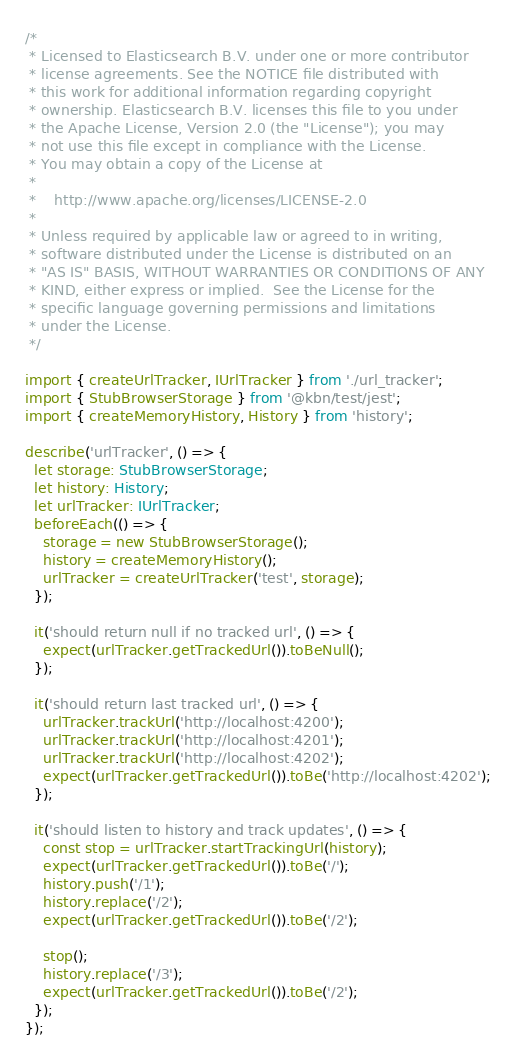<code> <loc_0><loc_0><loc_500><loc_500><_TypeScript_>/*
 * Licensed to Elasticsearch B.V. under one or more contributor
 * license agreements. See the NOTICE file distributed with
 * this work for additional information regarding copyright
 * ownership. Elasticsearch B.V. licenses this file to you under
 * the Apache License, Version 2.0 (the "License"); you may
 * not use this file except in compliance with the License.
 * You may obtain a copy of the License at
 *
 *    http://www.apache.org/licenses/LICENSE-2.0
 *
 * Unless required by applicable law or agreed to in writing,
 * software distributed under the License is distributed on an
 * "AS IS" BASIS, WITHOUT WARRANTIES OR CONDITIONS OF ANY
 * KIND, either express or implied.  See the License for the
 * specific language governing permissions and limitations
 * under the License.
 */

import { createUrlTracker, IUrlTracker } from './url_tracker';
import { StubBrowserStorage } from '@kbn/test/jest';
import { createMemoryHistory, History } from 'history';

describe('urlTracker', () => {
  let storage: StubBrowserStorage;
  let history: History;
  let urlTracker: IUrlTracker;
  beforeEach(() => {
    storage = new StubBrowserStorage();
    history = createMemoryHistory();
    urlTracker = createUrlTracker('test', storage);
  });

  it('should return null if no tracked url', () => {
    expect(urlTracker.getTrackedUrl()).toBeNull();
  });

  it('should return last tracked url', () => {
    urlTracker.trackUrl('http://localhost:4200');
    urlTracker.trackUrl('http://localhost:4201');
    urlTracker.trackUrl('http://localhost:4202');
    expect(urlTracker.getTrackedUrl()).toBe('http://localhost:4202');
  });

  it('should listen to history and track updates', () => {
    const stop = urlTracker.startTrackingUrl(history);
    expect(urlTracker.getTrackedUrl()).toBe('/');
    history.push('/1');
    history.replace('/2');
    expect(urlTracker.getTrackedUrl()).toBe('/2');

    stop();
    history.replace('/3');
    expect(urlTracker.getTrackedUrl()).toBe('/2');
  });
});
</code> 